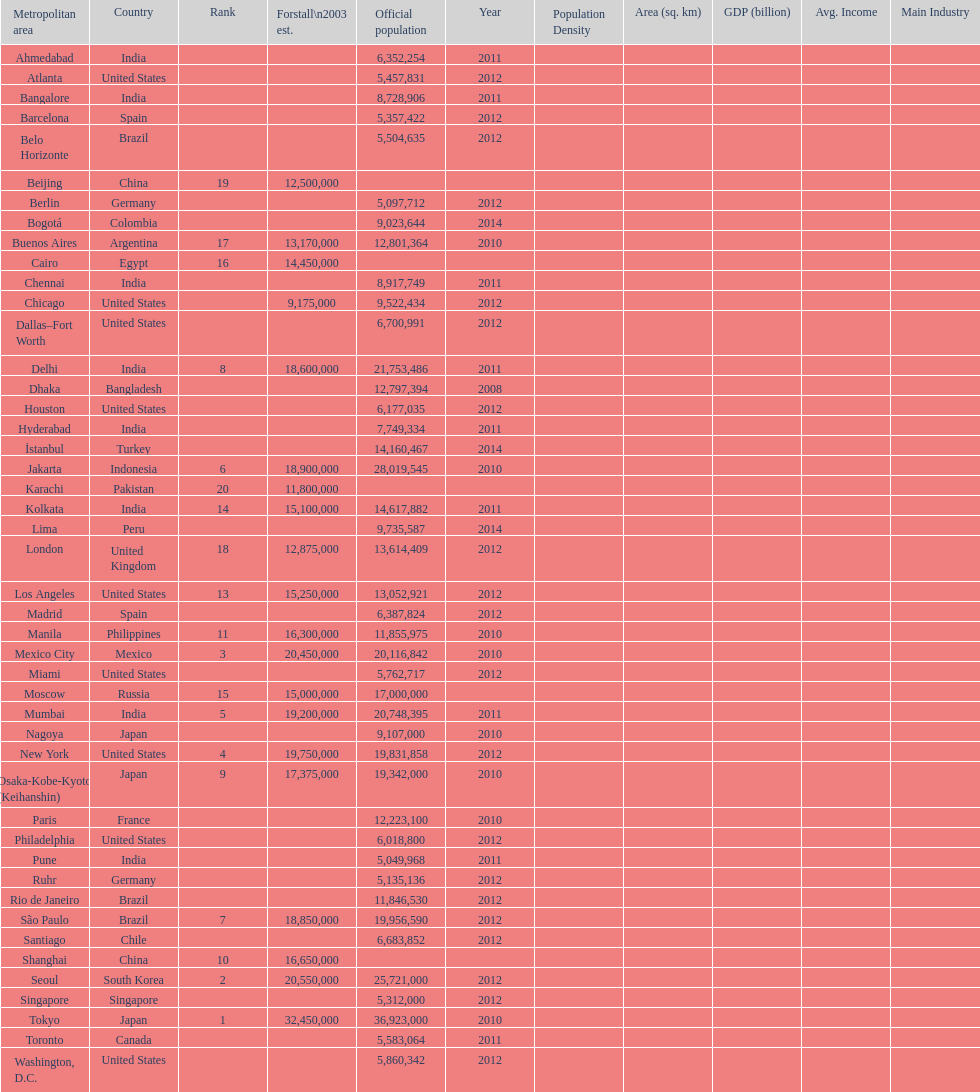Which population is listed before 5,357,422? 8,728,906. 